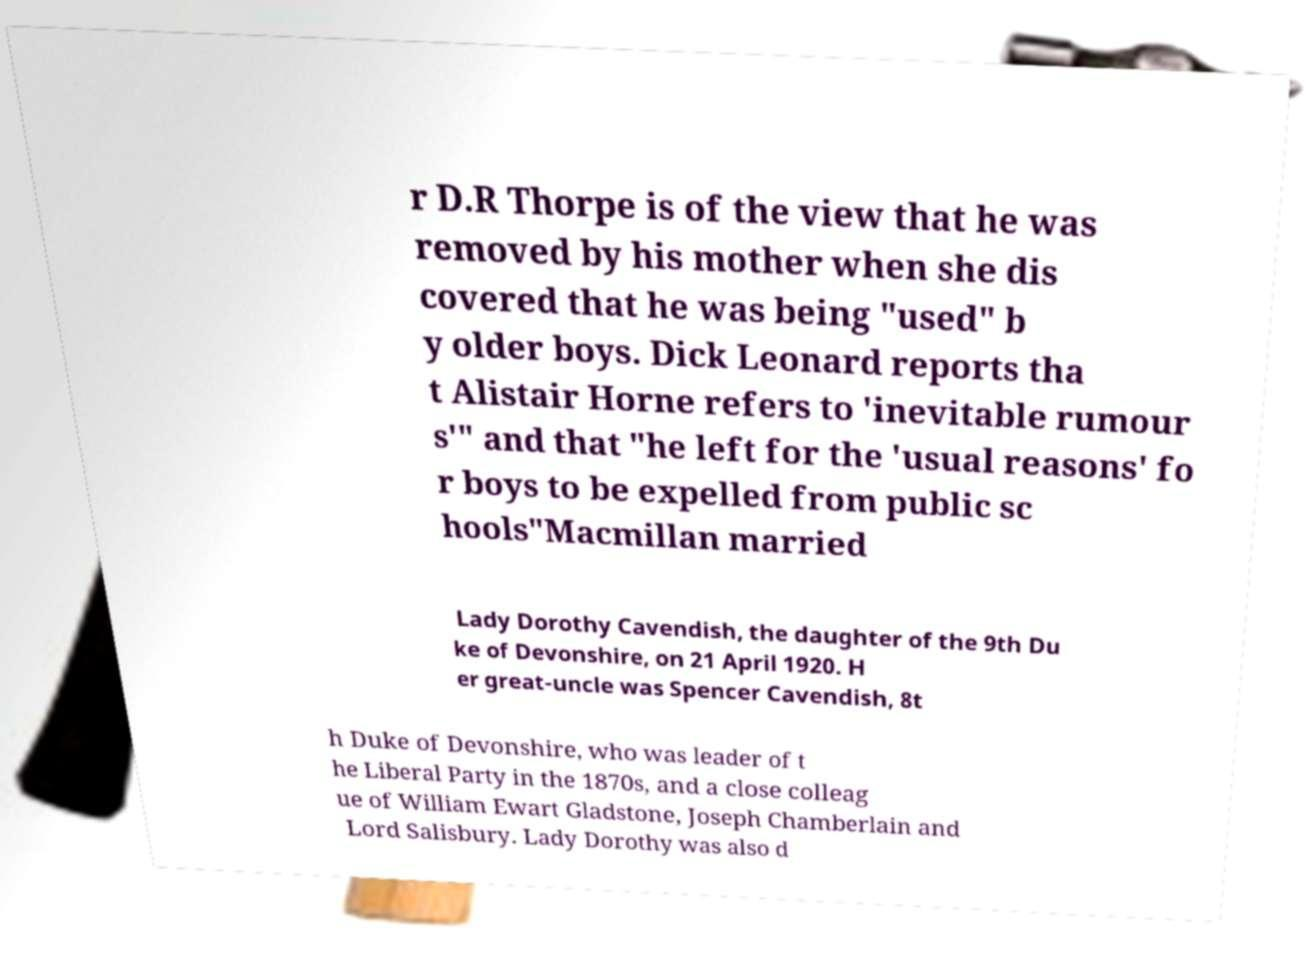For documentation purposes, I need the text within this image transcribed. Could you provide that? r D.R Thorpe is of the view that he was removed by his mother when she dis covered that he was being "used" b y older boys. Dick Leonard reports tha t Alistair Horne refers to 'inevitable rumour s'" and that "he left for the 'usual reasons' fo r boys to be expelled from public sc hools"Macmillan married Lady Dorothy Cavendish, the daughter of the 9th Du ke of Devonshire, on 21 April 1920. H er great-uncle was Spencer Cavendish, 8t h Duke of Devonshire, who was leader of t he Liberal Party in the 1870s, and a close colleag ue of William Ewart Gladstone, Joseph Chamberlain and Lord Salisbury. Lady Dorothy was also d 